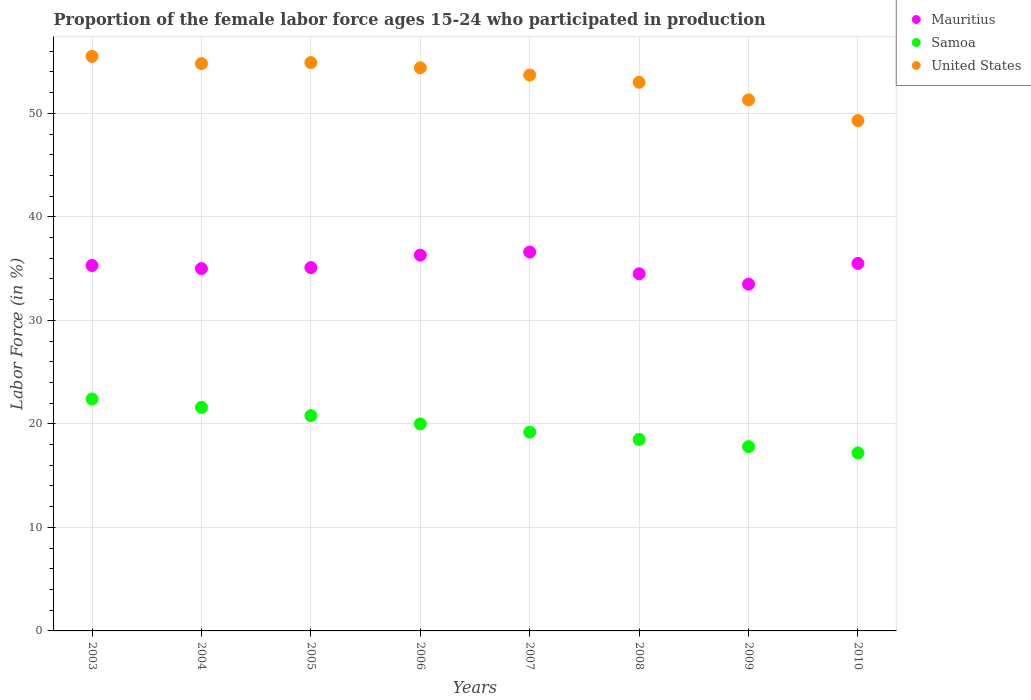How many different coloured dotlines are there?
Keep it short and to the point. 3. What is the proportion of the female labor force who participated in production in United States in 2004?
Offer a terse response. 54.8. Across all years, what is the maximum proportion of the female labor force who participated in production in Samoa?
Your answer should be compact. 22.4. Across all years, what is the minimum proportion of the female labor force who participated in production in United States?
Offer a terse response. 49.3. In which year was the proportion of the female labor force who participated in production in Samoa maximum?
Provide a succinct answer. 2003. What is the total proportion of the female labor force who participated in production in United States in the graph?
Offer a very short reply. 426.9. What is the difference between the proportion of the female labor force who participated in production in Samoa in 2007 and that in 2009?
Provide a short and direct response. 1.4. What is the difference between the proportion of the female labor force who participated in production in Samoa in 2004 and the proportion of the female labor force who participated in production in United States in 2005?
Provide a short and direct response. -33.3. What is the average proportion of the female labor force who participated in production in Mauritius per year?
Make the answer very short. 35.22. In the year 2004, what is the difference between the proportion of the female labor force who participated in production in Mauritius and proportion of the female labor force who participated in production in United States?
Ensure brevity in your answer.  -19.8. In how many years, is the proportion of the female labor force who participated in production in Mauritius greater than 12 %?
Make the answer very short. 8. What is the ratio of the proportion of the female labor force who participated in production in Samoa in 2005 to that in 2007?
Keep it short and to the point. 1.08. What is the difference between the highest and the second highest proportion of the female labor force who participated in production in Mauritius?
Your answer should be very brief. 0.3. What is the difference between the highest and the lowest proportion of the female labor force who participated in production in Mauritius?
Offer a terse response. 3.1. In how many years, is the proportion of the female labor force who participated in production in Mauritius greater than the average proportion of the female labor force who participated in production in Mauritius taken over all years?
Offer a terse response. 4. Is the proportion of the female labor force who participated in production in Mauritius strictly greater than the proportion of the female labor force who participated in production in Samoa over the years?
Your answer should be compact. Yes. Is the proportion of the female labor force who participated in production in Samoa strictly less than the proportion of the female labor force who participated in production in Mauritius over the years?
Provide a succinct answer. Yes. How many dotlines are there?
Ensure brevity in your answer.  3. Does the graph contain grids?
Offer a terse response. Yes. How many legend labels are there?
Provide a short and direct response. 3. What is the title of the graph?
Make the answer very short. Proportion of the female labor force ages 15-24 who participated in production. What is the label or title of the X-axis?
Ensure brevity in your answer.  Years. What is the label or title of the Y-axis?
Your answer should be compact. Labor Force (in %). What is the Labor Force (in %) in Mauritius in 2003?
Your answer should be very brief. 35.3. What is the Labor Force (in %) of Samoa in 2003?
Provide a succinct answer. 22.4. What is the Labor Force (in %) in United States in 2003?
Your answer should be compact. 55.5. What is the Labor Force (in %) of Mauritius in 2004?
Ensure brevity in your answer.  35. What is the Labor Force (in %) of Samoa in 2004?
Provide a short and direct response. 21.6. What is the Labor Force (in %) in United States in 2004?
Your answer should be compact. 54.8. What is the Labor Force (in %) in Mauritius in 2005?
Give a very brief answer. 35.1. What is the Labor Force (in %) of Samoa in 2005?
Provide a succinct answer. 20.8. What is the Labor Force (in %) in United States in 2005?
Your answer should be very brief. 54.9. What is the Labor Force (in %) in Mauritius in 2006?
Give a very brief answer. 36.3. What is the Labor Force (in %) in Samoa in 2006?
Make the answer very short. 20. What is the Labor Force (in %) of United States in 2006?
Offer a terse response. 54.4. What is the Labor Force (in %) of Mauritius in 2007?
Your response must be concise. 36.6. What is the Labor Force (in %) in Samoa in 2007?
Ensure brevity in your answer.  19.2. What is the Labor Force (in %) in United States in 2007?
Your answer should be very brief. 53.7. What is the Labor Force (in %) in Mauritius in 2008?
Offer a terse response. 34.5. What is the Labor Force (in %) of Samoa in 2008?
Offer a terse response. 18.5. What is the Labor Force (in %) of Mauritius in 2009?
Give a very brief answer. 33.5. What is the Labor Force (in %) in Samoa in 2009?
Your response must be concise. 17.8. What is the Labor Force (in %) of United States in 2009?
Keep it short and to the point. 51.3. What is the Labor Force (in %) of Mauritius in 2010?
Offer a very short reply. 35.5. What is the Labor Force (in %) of Samoa in 2010?
Offer a terse response. 17.2. What is the Labor Force (in %) of United States in 2010?
Provide a short and direct response. 49.3. Across all years, what is the maximum Labor Force (in %) in Mauritius?
Ensure brevity in your answer.  36.6. Across all years, what is the maximum Labor Force (in %) of Samoa?
Give a very brief answer. 22.4. Across all years, what is the maximum Labor Force (in %) in United States?
Offer a very short reply. 55.5. Across all years, what is the minimum Labor Force (in %) of Mauritius?
Provide a short and direct response. 33.5. Across all years, what is the minimum Labor Force (in %) of Samoa?
Give a very brief answer. 17.2. Across all years, what is the minimum Labor Force (in %) of United States?
Your response must be concise. 49.3. What is the total Labor Force (in %) in Mauritius in the graph?
Ensure brevity in your answer.  281.8. What is the total Labor Force (in %) of Samoa in the graph?
Make the answer very short. 157.5. What is the total Labor Force (in %) in United States in the graph?
Offer a very short reply. 426.9. What is the difference between the Labor Force (in %) in Samoa in 2003 and that in 2004?
Offer a very short reply. 0.8. What is the difference between the Labor Force (in %) in United States in 2003 and that in 2005?
Offer a terse response. 0.6. What is the difference between the Labor Force (in %) in Samoa in 2003 and that in 2006?
Give a very brief answer. 2.4. What is the difference between the Labor Force (in %) of United States in 2003 and that in 2006?
Provide a succinct answer. 1.1. What is the difference between the Labor Force (in %) in Mauritius in 2003 and that in 2008?
Provide a short and direct response. 0.8. What is the difference between the Labor Force (in %) in United States in 2003 and that in 2008?
Provide a short and direct response. 2.5. What is the difference between the Labor Force (in %) of Mauritius in 2003 and that in 2010?
Offer a very short reply. -0.2. What is the difference between the Labor Force (in %) in Mauritius in 2004 and that in 2005?
Provide a succinct answer. -0.1. What is the difference between the Labor Force (in %) of United States in 2004 and that in 2005?
Offer a terse response. -0.1. What is the difference between the Labor Force (in %) in United States in 2004 and that in 2006?
Your answer should be very brief. 0.4. What is the difference between the Labor Force (in %) in Samoa in 2004 and that in 2007?
Keep it short and to the point. 2.4. What is the difference between the Labor Force (in %) of United States in 2004 and that in 2007?
Provide a succinct answer. 1.1. What is the difference between the Labor Force (in %) in United States in 2004 and that in 2008?
Your response must be concise. 1.8. What is the difference between the Labor Force (in %) of Mauritius in 2004 and that in 2009?
Your response must be concise. 1.5. What is the difference between the Labor Force (in %) in Samoa in 2004 and that in 2009?
Make the answer very short. 3.8. What is the difference between the Labor Force (in %) in United States in 2004 and that in 2009?
Offer a very short reply. 3.5. What is the difference between the Labor Force (in %) of Samoa in 2004 and that in 2010?
Provide a short and direct response. 4.4. What is the difference between the Labor Force (in %) of Mauritius in 2005 and that in 2006?
Your answer should be very brief. -1.2. What is the difference between the Labor Force (in %) of Samoa in 2005 and that in 2006?
Offer a terse response. 0.8. What is the difference between the Labor Force (in %) of United States in 2005 and that in 2008?
Provide a short and direct response. 1.9. What is the difference between the Labor Force (in %) in Mauritius in 2005 and that in 2009?
Make the answer very short. 1.6. What is the difference between the Labor Force (in %) of Samoa in 2005 and that in 2009?
Your answer should be very brief. 3. What is the difference between the Labor Force (in %) of Mauritius in 2005 and that in 2010?
Keep it short and to the point. -0.4. What is the difference between the Labor Force (in %) of Samoa in 2006 and that in 2007?
Give a very brief answer. 0.8. What is the difference between the Labor Force (in %) of Samoa in 2006 and that in 2009?
Your answer should be very brief. 2.2. What is the difference between the Labor Force (in %) of United States in 2006 and that in 2009?
Keep it short and to the point. 3.1. What is the difference between the Labor Force (in %) in United States in 2006 and that in 2010?
Ensure brevity in your answer.  5.1. What is the difference between the Labor Force (in %) in Samoa in 2007 and that in 2008?
Offer a terse response. 0.7. What is the difference between the Labor Force (in %) in Mauritius in 2007 and that in 2009?
Provide a short and direct response. 3.1. What is the difference between the Labor Force (in %) of Samoa in 2007 and that in 2009?
Your answer should be compact. 1.4. What is the difference between the Labor Force (in %) of Mauritius in 2007 and that in 2010?
Your answer should be compact. 1.1. What is the difference between the Labor Force (in %) of United States in 2007 and that in 2010?
Provide a short and direct response. 4.4. What is the difference between the Labor Force (in %) in Mauritius in 2008 and that in 2009?
Provide a succinct answer. 1. What is the difference between the Labor Force (in %) in Samoa in 2008 and that in 2009?
Provide a succinct answer. 0.7. What is the difference between the Labor Force (in %) in Mauritius in 2008 and that in 2010?
Ensure brevity in your answer.  -1. What is the difference between the Labor Force (in %) in Samoa in 2008 and that in 2010?
Provide a succinct answer. 1.3. What is the difference between the Labor Force (in %) in United States in 2008 and that in 2010?
Your answer should be very brief. 3.7. What is the difference between the Labor Force (in %) of Mauritius in 2009 and that in 2010?
Your answer should be very brief. -2. What is the difference between the Labor Force (in %) in Mauritius in 2003 and the Labor Force (in %) in Samoa in 2004?
Your answer should be compact. 13.7. What is the difference between the Labor Force (in %) of Mauritius in 2003 and the Labor Force (in %) of United States in 2004?
Your response must be concise. -19.5. What is the difference between the Labor Force (in %) in Samoa in 2003 and the Labor Force (in %) in United States in 2004?
Offer a very short reply. -32.4. What is the difference between the Labor Force (in %) in Mauritius in 2003 and the Labor Force (in %) in Samoa in 2005?
Your answer should be very brief. 14.5. What is the difference between the Labor Force (in %) in Mauritius in 2003 and the Labor Force (in %) in United States in 2005?
Provide a succinct answer. -19.6. What is the difference between the Labor Force (in %) in Samoa in 2003 and the Labor Force (in %) in United States in 2005?
Give a very brief answer. -32.5. What is the difference between the Labor Force (in %) in Mauritius in 2003 and the Labor Force (in %) in Samoa in 2006?
Your answer should be very brief. 15.3. What is the difference between the Labor Force (in %) of Mauritius in 2003 and the Labor Force (in %) of United States in 2006?
Provide a short and direct response. -19.1. What is the difference between the Labor Force (in %) in Samoa in 2003 and the Labor Force (in %) in United States in 2006?
Provide a short and direct response. -32. What is the difference between the Labor Force (in %) of Mauritius in 2003 and the Labor Force (in %) of Samoa in 2007?
Your response must be concise. 16.1. What is the difference between the Labor Force (in %) in Mauritius in 2003 and the Labor Force (in %) in United States in 2007?
Your answer should be very brief. -18.4. What is the difference between the Labor Force (in %) of Samoa in 2003 and the Labor Force (in %) of United States in 2007?
Offer a terse response. -31.3. What is the difference between the Labor Force (in %) of Mauritius in 2003 and the Labor Force (in %) of United States in 2008?
Offer a terse response. -17.7. What is the difference between the Labor Force (in %) in Samoa in 2003 and the Labor Force (in %) in United States in 2008?
Keep it short and to the point. -30.6. What is the difference between the Labor Force (in %) in Mauritius in 2003 and the Labor Force (in %) in Samoa in 2009?
Your answer should be very brief. 17.5. What is the difference between the Labor Force (in %) in Samoa in 2003 and the Labor Force (in %) in United States in 2009?
Provide a short and direct response. -28.9. What is the difference between the Labor Force (in %) in Mauritius in 2003 and the Labor Force (in %) in United States in 2010?
Offer a terse response. -14. What is the difference between the Labor Force (in %) of Samoa in 2003 and the Labor Force (in %) of United States in 2010?
Offer a terse response. -26.9. What is the difference between the Labor Force (in %) of Mauritius in 2004 and the Labor Force (in %) of Samoa in 2005?
Your response must be concise. 14.2. What is the difference between the Labor Force (in %) in Mauritius in 2004 and the Labor Force (in %) in United States in 2005?
Your answer should be very brief. -19.9. What is the difference between the Labor Force (in %) in Samoa in 2004 and the Labor Force (in %) in United States in 2005?
Ensure brevity in your answer.  -33.3. What is the difference between the Labor Force (in %) in Mauritius in 2004 and the Labor Force (in %) in United States in 2006?
Keep it short and to the point. -19.4. What is the difference between the Labor Force (in %) of Samoa in 2004 and the Labor Force (in %) of United States in 2006?
Give a very brief answer. -32.8. What is the difference between the Labor Force (in %) of Mauritius in 2004 and the Labor Force (in %) of Samoa in 2007?
Your answer should be very brief. 15.8. What is the difference between the Labor Force (in %) in Mauritius in 2004 and the Labor Force (in %) in United States in 2007?
Make the answer very short. -18.7. What is the difference between the Labor Force (in %) of Samoa in 2004 and the Labor Force (in %) of United States in 2007?
Provide a short and direct response. -32.1. What is the difference between the Labor Force (in %) of Mauritius in 2004 and the Labor Force (in %) of Samoa in 2008?
Provide a succinct answer. 16.5. What is the difference between the Labor Force (in %) of Mauritius in 2004 and the Labor Force (in %) of United States in 2008?
Ensure brevity in your answer.  -18. What is the difference between the Labor Force (in %) of Samoa in 2004 and the Labor Force (in %) of United States in 2008?
Make the answer very short. -31.4. What is the difference between the Labor Force (in %) in Mauritius in 2004 and the Labor Force (in %) in Samoa in 2009?
Keep it short and to the point. 17.2. What is the difference between the Labor Force (in %) of Mauritius in 2004 and the Labor Force (in %) of United States in 2009?
Your answer should be very brief. -16.3. What is the difference between the Labor Force (in %) of Samoa in 2004 and the Labor Force (in %) of United States in 2009?
Provide a succinct answer. -29.7. What is the difference between the Labor Force (in %) in Mauritius in 2004 and the Labor Force (in %) in Samoa in 2010?
Offer a very short reply. 17.8. What is the difference between the Labor Force (in %) of Mauritius in 2004 and the Labor Force (in %) of United States in 2010?
Your response must be concise. -14.3. What is the difference between the Labor Force (in %) of Samoa in 2004 and the Labor Force (in %) of United States in 2010?
Give a very brief answer. -27.7. What is the difference between the Labor Force (in %) of Mauritius in 2005 and the Labor Force (in %) of United States in 2006?
Your answer should be very brief. -19.3. What is the difference between the Labor Force (in %) of Samoa in 2005 and the Labor Force (in %) of United States in 2006?
Make the answer very short. -33.6. What is the difference between the Labor Force (in %) in Mauritius in 2005 and the Labor Force (in %) in United States in 2007?
Offer a terse response. -18.6. What is the difference between the Labor Force (in %) in Samoa in 2005 and the Labor Force (in %) in United States in 2007?
Provide a short and direct response. -32.9. What is the difference between the Labor Force (in %) of Mauritius in 2005 and the Labor Force (in %) of Samoa in 2008?
Ensure brevity in your answer.  16.6. What is the difference between the Labor Force (in %) in Mauritius in 2005 and the Labor Force (in %) in United States in 2008?
Offer a very short reply. -17.9. What is the difference between the Labor Force (in %) in Samoa in 2005 and the Labor Force (in %) in United States in 2008?
Offer a terse response. -32.2. What is the difference between the Labor Force (in %) of Mauritius in 2005 and the Labor Force (in %) of United States in 2009?
Your response must be concise. -16.2. What is the difference between the Labor Force (in %) of Samoa in 2005 and the Labor Force (in %) of United States in 2009?
Provide a succinct answer. -30.5. What is the difference between the Labor Force (in %) of Mauritius in 2005 and the Labor Force (in %) of United States in 2010?
Keep it short and to the point. -14.2. What is the difference between the Labor Force (in %) in Samoa in 2005 and the Labor Force (in %) in United States in 2010?
Ensure brevity in your answer.  -28.5. What is the difference between the Labor Force (in %) in Mauritius in 2006 and the Labor Force (in %) in Samoa in 2007?
Make the answer very short. 17.1. What is the difference between the Labor Force (in %) in Mauritius in 2006 and the Labor Force (in %) in United States in 2007?
Provide a succinct answer. -17.4. What is the difference between the Labor Force (in %) in Samoa in 2006 and the Labor Force (in %) in United States in 2007?
Your answer should be very brief. -33.7. What is the difference between the Labor Force (in %) of Mauritius in 2006 and the Labor Force (in %) of United States in 2008?
Offer a terse response. -16.7. What is the difference between the Labor Force (in %) of Samoa in 2006 and the Labor Force (in %) of United States in 2008?
Provide a short and direct response. -33. What is the difference between the Labor Force (in %) of Mauritius in 2006 and the Labor Force (in %) of United States in 2009?
Make the answer very short. -15. What is the difference between the Labor Force (in %) in Samoa in 2006 and the Labor Force (in %) in United States in 2009?
Keep it short and to the point. -31.3. What is the difference between the Labor Force (in %) in Samoa in 2006 and the Labor Force (in %) in United States in 2010?
Keep it short and to the point. -29.3. What is the difference between the Labor Force (in %) in Mauritius in 2007 and the Labor Force (in %) in Samoa in 2008?
Provide a succinct answer. 18.1. What is the difference between the Labor Force (in %) of Mauritius in 2007 and the Labor Force (in %) of United States in 2008?
Ensure brevity in your answer.  -16.4. What is the difference between the Labor Force (in %) in Samoa in 2007 and the Labor Force (in %) in United States in 2008?
Ensure brevity in your answer.  -33.8. What is the difference between the Labor Force (in %) in Mauritius in 2007 and the Labor Force (in %) in Samoa in 2009?
Provide a short and direct response. 18.8. What is the difference between the Labor Force (in %) of Mauritius in 2007 and the Labor Force (in %) of United States in 2009?
Provide a short and direct response. -14.7. What is the difference between the Labor Force (in %) of Samoa in 2007 and the Labor Force (in %) of United States in 2009?
Give a very brief answer. -32.1. What is the difference between the Labor Force (in %) of Samoa in 2007 and the Labor Force (in %) of United States in 2010?
Your answer should be very brief. -30.1. What is the difference between the Labor Force (in %) of Mauritius in 2008 and the Labor Force (in %) of Samoa in 2009?
Offer a terse response. 16.7. What is the difference between the Labor Force (in %) of Mauritius in 2008 and the Labor Force (in %) of United States in 2009?
Your answer should be compact. -16.8. What is the difference between the Labor Force (in %) of Samoa in 2008 and the Labor Force (in %) of United States in 2009?
Make the answer very short. -32.8. What is the difference between the Labor Force (in %) of Mauritius in 2008 and the Labor Force (in %) of Samoa in 2010?
Keep it short and to the point. 17.3. What is the difference between the Labor Force (in %) of Mauritius in 2008 and the Labor Force (in %) of United States in 2010?
Provide a short and direct response. -14.8. What is the difference between the Labor Force (in %) of Samoa in 2008 and the Labor Force (in %) of United States in 2010?
Give a very brief answer. -30.8. What is the difference between the Labor Force (in %) in Mauritius in 2009 and the Labor Force (in %) in Samoa in 2010?
Your answer should be compact. 16.3. What is the difference between the Labor Force (in %) in Mauritius in 2009 and the Labor Force (in %) in United States in 2010?
Provide a short and direct response. -15.8. What is the difference between the Labor Force (in %) in Samoa in 2009 and the Labor Force (in %) in United States in 2010?
Give a very brief answer. -31.5. What is the average Labor Force (in %) of Mauritius per year?
Provide a succinct answer. 35.23. What is the average Labor Force (in %) of Samoa per year?
Provide a short and direct response. 19.69. What is the average Labor Force (in %) in United States per year?
Provide a succinct answer. 53.36. In the year 2003, what is the difference between the Labor Force (in %) in Mauritius and Labor Force (in %) in United States?
Provide a succinct answer. -20.2. In the year 2003, what is the difference between the Labor Force (in %) of Samoa and Labor Force (in %) of United States?
Give a very brief answer. -33.1. In the year 2004, what is the difference between the Labor Force (in %) of Mauritius and Labor Force (in %) of Samoa?
Provide a succinct answer. 13.4. In the year 2004, what is the difference between the Labor Force (in %) in Mauritius and Labor Force (in %) in United States?
Provide a succinct answer. -19.8. In the year 2004, what is the difference between the Labor Force (in %) of Samoa and Labor Force (in %) of United States?
Provide a short and direct response. -33.2. In the year 2005, what is the difference between the Labor Force (in %) in Mauritius and Labor Force (in %) in United States?
Keep it short and to the point. -19.8. In the year 2005, what is the difference between the Labor Force (in %) in Samoa and Labor Force (in %) in United States?
Make the answer very short. -34.1. In the year 2006, what is the difference between the Labor Force (in %) of Mauritius and Labor Force (in %) of United States?
Your answer should be very brief. -18.1. In the year 2006, what is the difference between the Labor Force (in %) in Samoa and Labor Force (in %) in United States?
Offer a very short reply. -34.4. In the year 2007, what is the difference between the Labor Force (in %) of Mauritius and Labor Force (in %) of United States?
Your answer should be compact. -17.1. In the year 2007, what is the difference between the Labor Force (in %) in Samoa and Labor Force (in %) in United States?
Give a very brief answer. -34.5. In the year 2008, what is the difference between the Labor Force (in %) in Mauritius and Labor Force (in %) in United States?
Your response must be concise. -18.5. In the year 2008, what is the difference between the Labor Force (in %) in Samoa and Labor Force (in %) in United States?
Ensure brevity in your answer.  -34.5. In the year 2009, what is the difference between the Labor Force (in %) of Mauritius and Labor Force (in %) of Samoa?
Offer a terse response. 15.7. In the year 2009, what is the difference between the Labor Force (in %) of Mauritius and Labor Force (in %) of United States?
Ensure brevity in your answer.  -17.8. In the year 2009, what is the difference between the Labor Force (in %) in Samoa and Labor Force (in %) in United States?
Provide a short and direct response. -33.5. In the year 2010, what is the difference between the Labor Force (in %) in Mauritius and Labor Force (in %) in United States?
Provide a succinct answer. -13.8. In the year 2010, what is the difference between the Labor Force (in %) of Samoa and Labor Force (in %) of United States?
Provide a short and direct response. -32.1. What is the ratio of the Labor Force (in %) in Mauritius in 2003 to that in 2004?
Your response must be concise. 1.01. What is the ratio of the Labor Force (in %) in Samoa in 2003 to that in 2004?
Provide a succinct answer. 1.04. What is the ratio of the Labor Force (in %) of United States in 2003 to that in 2004?
Offer a very short reply. 1.01. What is the ratio of the Labor Force (in %) in Mauritius in 2003 to that in 2005?
Your answer should be compact. 1.01. What is the ratio of the Labor Force (in %) in United States in 2003 to that in 2005?
Your answer should be compact. 1.01. What is the ratio of the Labor Force (in %) of Mauritius in 2003 to that in 2006?
Keep it short and to the point. 0.97. What is the ratio of the Labor Force (in %) of Samoa in 2003 to that in 2006?
Make the answer very short. 1.12. What is the ratio of the Labor Force (in %) in United States in 2003 to that in 2006?
Keep it short and to the point. 1.02. What is the ratio of the Labor Force (in %) in Mauritius in 2003 to that in 2007?
Your answer should be compact. 0.96. What is the ratio of the Labor Force (in %) of United States in 2003 to that in 2007?
Provide a succinct answer. 1.03. What is the ratio of the Labor Force (in %) in Mauritius in 2003 to that in 2008?
Your response must be concise. 1.02. What is the ratio of the Labor Force (in %) in Samoa in 2003 to that in 2008?
Make the answer very short. 1.21. What is the ratio of the Labor Force (in %) in United States in 2003 to that in 2008?
Offer a very short reply. 1.05. What is the ratio of the Labor Force (in %) of Mauritius in 2003 to that in 2009?
Your answer should be compact. 1.05. What is the ratio of the Labor Force (in %) of Samoa in 2003 to that in 2009?
Your response must be concise. 1.26. What is the ratio of the Labor Force (in %) of United States in 2003 to that in 2009?
Make the answer very short. 1.08. What is the ratio of the Labor Force (in %) in Samoa in 2003 to that in 2010?
Offer a terse response. 1.3. What is the ratio of the Labor Force (in %) of United States in 2003 to that in 2010?
Ensure brevity in your answer.  1.13. What is the ratio of the Labor Force (in %) in Mauritius in 2004 to that in 2005?
Make the answer very short. 1. What is the ratio of the Labor Force (in %) of Samoa in 2004 to that in 2005?
Offer a terse response. 1.04. What is the ratio of the Labor Force (in %) in United States in 2004 to that in 2005?
Offer a very short reply. 1. What is the ratio of the Labor Force (in %) in Mauritius in 2004 to that in 2006?
Offer a very short reply. 0.96. What is the ratio of the Labor Force (in %) in United States in 2004 to that in 2006?
Provide a succinct answer. 1.01. What is the ratio of the Labor Force (in %) in Mauritius in 2004 to that in 2007?
Your answer should be very brief. 0.96. What is the ratio of the Labor Force (in %) in United States in 2004 to that in 2007?
Provide a short and direct response. 1.02. What is the ratio of the Labor Force (in %) in Mauritius in 2004 to that in 2008?
Offer a terse response. 1.01. What is the ratio of the Labor Force (in %) in Samoa in 2004 to that in 2008?
Your answer should be compact. 1.17. What is the ratio of the Labor Force (in %) in United States in 2004 to that in 2008?
Make the answer very short. 1.03. What is the ratio of the Labor Force (in %) of Mauritius in 2004 to that in 2009?
Provide a succinct answer. 1.04. What is the ratio of the Labor Force (in %) in Samoa in 2004 to that in 2009?
Your answer should be compact. 1.21. What is the ratio of the Labor Force (in %) of United States in 2004 to that in 2009?
Your answer should be very brief. 1.07. What is the ratio of the Labor Force (in %) of Mauritius in 2004 to that in 2010?
Give a very brief answer. 0.99. What is the ratio of the Labor Force (in %) of Samoa in 2004 to that in 2010?
Your answer should be compact. 1.26. What is the ratio of the Labor Force (in %) of United States in 2004 to that in 2010?
Give a very brief answer. 1.11. What is the ratio of the Labor Force (in %) of Mauritius in 2005 to that in 2006?
Offer a very short reply. 0.97. What is the ratio of the Labor Force (in %) of Samoa in 2005 to that in 2006?
Provide a succinct answer. 1.04. What is the ratio of the Labor Force (in %) in United States in 2005 to that in 2006?
Your response must be concise. 1.01. What is the ratio of the Labor Force (in %) of United States in 2005 to that in 2007?
Provide a succinct answer. 1.02. What is the ratio of the Labor Force (in %) in Mauritius in 2005 to that in 2008?
Your response must be concise. 1.02. What is the ratio of the Labor Force (in %) in Samoa in 2005 to that in 2008?
Make the answer very short. 1.12. What is the ratio of the Labor Force (in %) in United States in 2005 to that in 2008?
Keep it short and to the point. 1.04. What is the ratio of the Labor Force (in %) in Mauritius in 2005 to that in 2009?
Keep it short and to the point. 1.05. What is the ratio of the Labor Force (in %) in Samoa in 2005 to that in 2009?
Offer a terse response. 1.17. What is the ratio of the Labor Force (in %) of United States in 2005 to that in 2009?
Give a very brief answer. 1.07. What is the ratio of the Labor Force (in %) in Mauritius in 2005 to that in 2010?
Offer a very short reply. 0.99. What is the ratio of the Labor Force (in %) in Samoa in 2005 to that in 2010?
Provide a succinct answer. 1.21. What is the ratio of the Labor Force (in %) in United States in 2005 to that in 2010?
Your response must be concise. 1.11. What is the ratio of the Labor Force (in %) of Samoa in 2006 to that in 2007?
Ensure brevity in your answer.  1.04. What is the ratio of the Labor Force (in %) in United States in 2006 to that in 2007?
Give a very brief answer. 1.01. What is the ratio of the Labor Force (in %) of Mauritius in 2006 to that in 2008?
Your response must be concise. 1.05. What is the ratio of the Labor Force (in %) of Samoa in 2006 to that in 2008?
Ensure brevity in your answer.  1.08. What is the ratio of the Labor Force (in %) of United States in 2006 to that in 2008?
Your response must be concise. 1.03. What is the ratio of the Labor Force (in %) of Mauritius in 2006 to that in 2009?
Your response must be concise. 1.08. What is the ratio of the Labor Force (in %) in Samoa in 2006 to that in 2009?
Provide a short and direct response. 1.12. What is the ratio of the Labor Force (in %) of United States in 2006 to that in 2009?
Offer a very short reply. 1.06. What is the ratio of the Labor Force (in %) of Mauritius in 2006 to that in 2010?
Your response must be concise. 1.02. What is the ratio of the Labor Force (in %) of Samoa in 2006 to that in 2010?
Make the answer very short. 1.16. What is the ratio of the Labor Force (in %) in United States in 2006 to that in 2010?
Offer a very short reply. 1.1. What is the ratio of the Labor Force (in %) of Mauritius in 2007 to that in 2008?
Make the answer very short. 1.06. What is the ratio of the Labor Force (in %) of Samoa in 2007 to that in 2008?
Provide a succinct answer. 1.04. What is the ratio of the Labor Force (in %) of United States in 2007 to that in 2008?
Keep it short and to the point. 1.01. What is the ratio of the Labor Force (in %) of Mauritius in 2007 to that in 2009?
Offer a very short reply. 1.09. What is the ratio of the Labor Force (in %) in Samoa in 2007 to that in 2009?
Offer a very short reply. 1.08. What is the ratio of the Labor Force (in %) in United States in 2007 to that in 2009?
Your answer should be very brief. 1.05. What is the ratio of the Labor Force (in %) of Mauritius in 2007 to that in 2010?
Your answer should be compact. 1.03. What is the ratio of the Labor Force (in %) of Samoa in 2007 to that in 2010?
Offer a terse response. 1.12. What is the ratio of the Labor Force (in %) of United States in 2007 to that in 2010?
Make the answer very short. 1.09. What is the ratio of the Labor Force (in %) in Mauritius in 2008 to that in 2009?
Offer a terse response. 1.03. What is the ratio of the Labor Force (in %) of Samoa in 2008 to that in 2009?
Offer a very short reply. 1.04. What is the ratio of the Labor Force (in %) of United States in 2008 to that in 2009?
Give a very brief answer. 1.03. What is the ratio of the Labor Force (in %) in Mauritius in 2008 to that in 2010?
Provide a succinct answer. 0.97. What is the ratio of the Labor Force (in %) in Samoa in 2008 to that in 2010?
Offer a terse response. 1.08. What is the ratio of the Labor Force (in %) of United States in 2008 to that in 2010?
Give a very brief answer. 1.08. What is the ratio of the Labor Force (in %) of Mauritius in 2009 to that in 2010?
Your response must be concise. 0.94. What is the ratio of the Labor Force (in %) of Samoa in 2009 to that in 2010?
Your response must be concise. 1.03. What is the ratio of the Labor Force (in %) of United States in 2009 to that in 2010?
Offer a terse response. 1.04. What is the difference between the highest and the second highest Labor Force (in %) in United States?
Your response must be concise. 0.6. What is the difference between the highest and the lowest Labor Force (in %) in United States?
Your response must be concise. 6.2. 